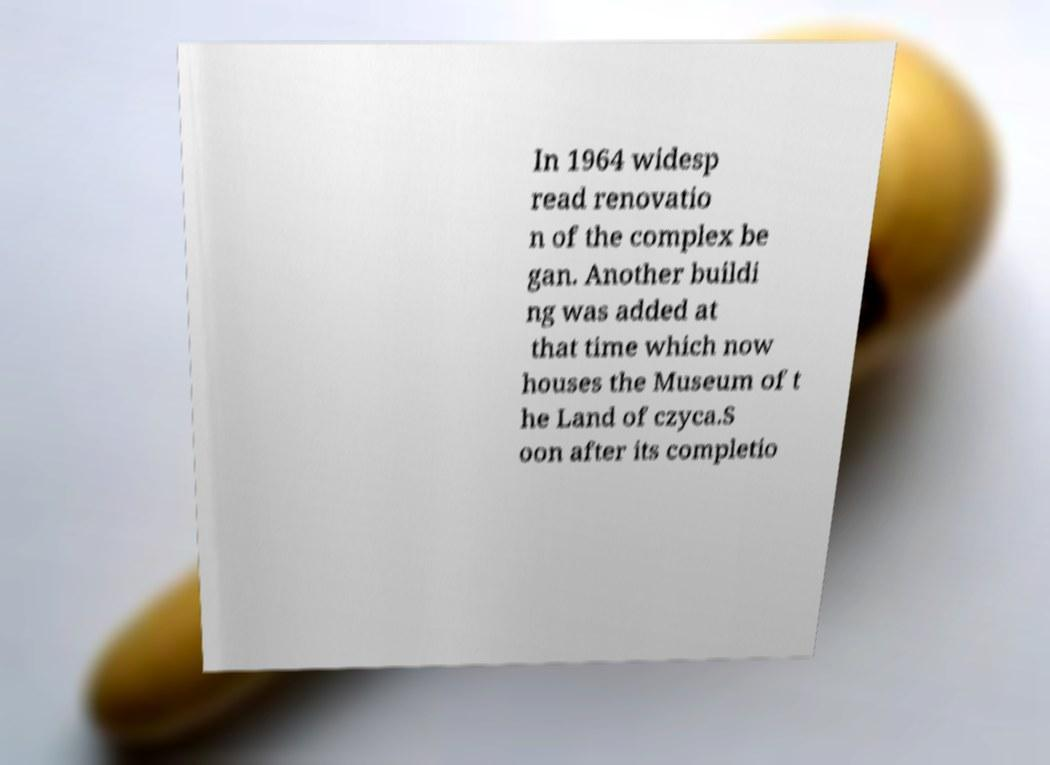There's text embedded in this image that I need extracted. Can you transcribe it verbatim? In 1964 widesp read renovatio n of the complex be gan. Another buildi ng was added at that time which now houses the Museum of t he Land of czyca.S oon after its completio 